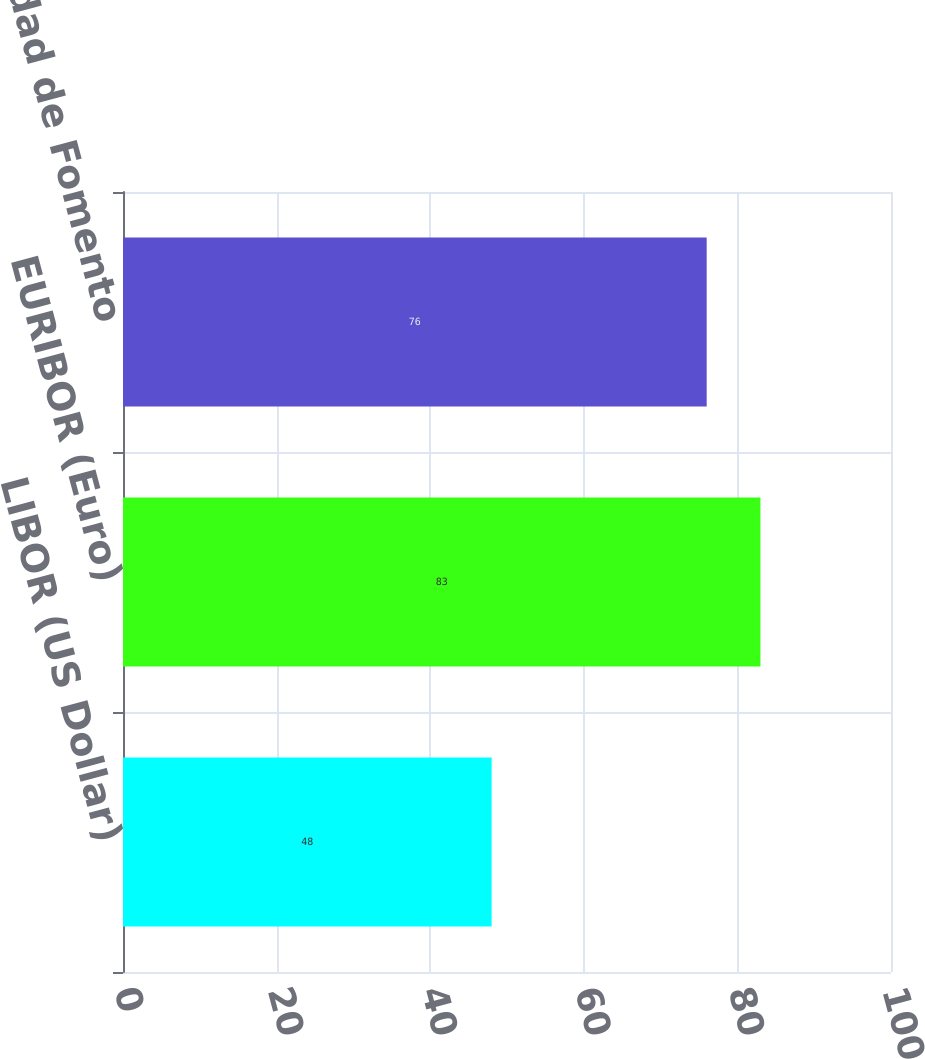Convert chart. <chart><loc_0><loc_0><loc_500><loc_500><bar_chart><fcel>LIBOR (US Dollar)<fcel>EURIBOR (Euro)<fcel>Chilean Unidad de Fomento<nl><fcel>48<fcel>83<fcel>76<nl></chart> 